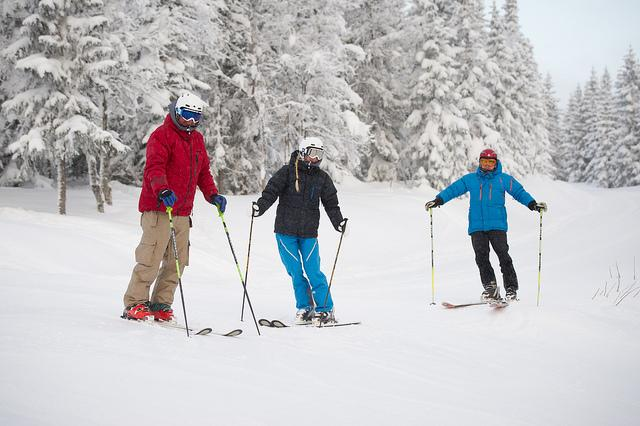A snowblade is made of what? Please explain your reasoning. wood. They are made of wood. 